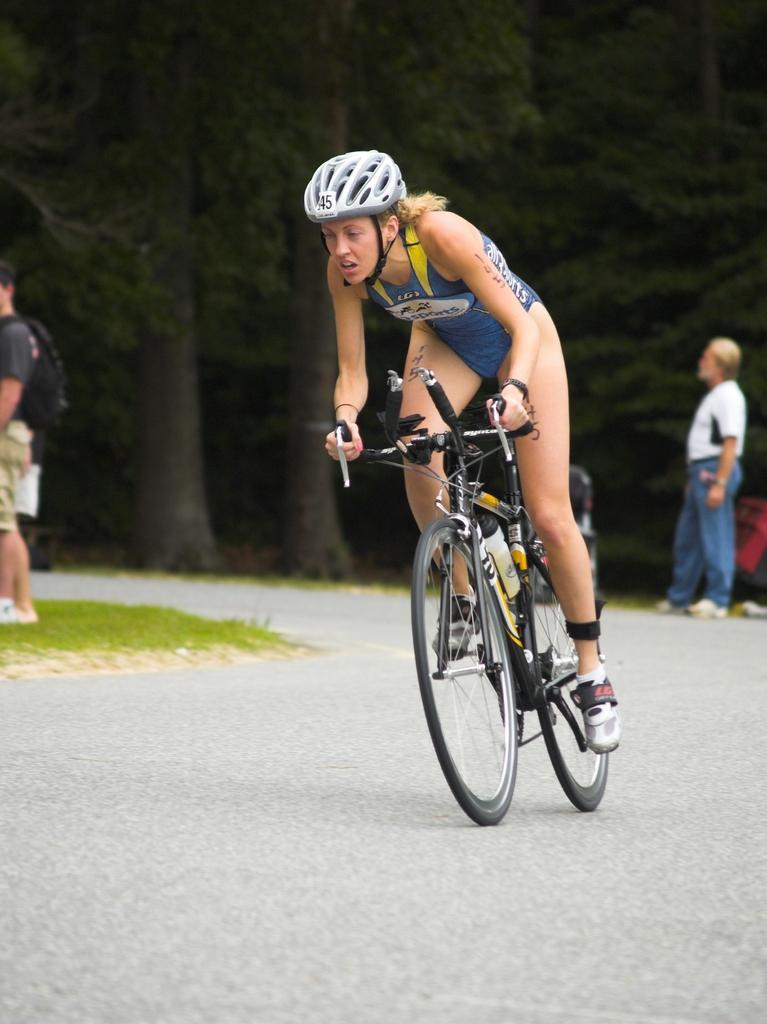How would you summarize this image in a sentence or two? In this picture there is a woman riding a bicycle on the road. She is wearing a blue dress and white helmet. Towards the left there is a person wearing a bag. Towards the right there is another person wearing white t shirt and blue jeans. In the background there are group of trees. 